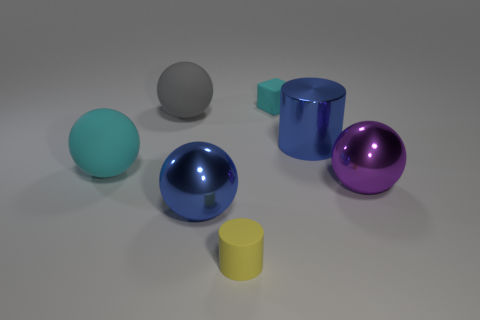Subtract all large purple metallic spheres. How many spheres are left? 3 Add 3 small yellow cylinders. How many objects exist? 10 Subtract all yellow cylinders. How many cylinders are left? 1 Subtract all cylinders. How many objects are left? 5 Subtract 1 spheres. How many spheres are left? 3 Subtract all green cubes. How many cyan cylinders are left? 0 Subtract all large purple metal objects. Subtract all blue metal cylinders. How many objects are left? 5 Add 3 cyan spheres. How many cyan spheres are left? 4 Add 4 purple balls. How many purple balls exist? 5 Subtract 0 red cylinders. How many objects are left? 7 